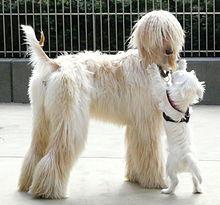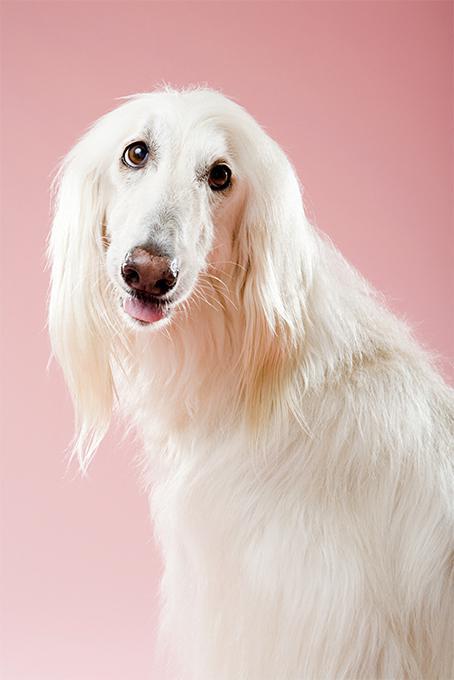The first image is the image on the left, the second image is the image on the right. Examine the images to the left and right. Is the description "One image has a tan and white dog standing on grass." accurate? Answer yes or no. No. The first image is the image on the left, the second image is the image on the right. Assess this claim about the two images: "In one image there is a lone afghan hound standing outside". Correct or not? Answer yes or no. No. 